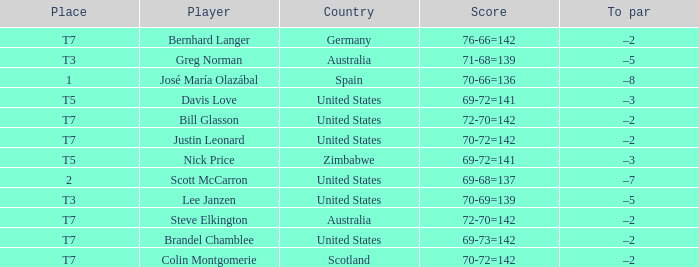Who is the Player with a Score of 70-72=142? Question 3 Justin Leonard, Colin Montgomerie. 